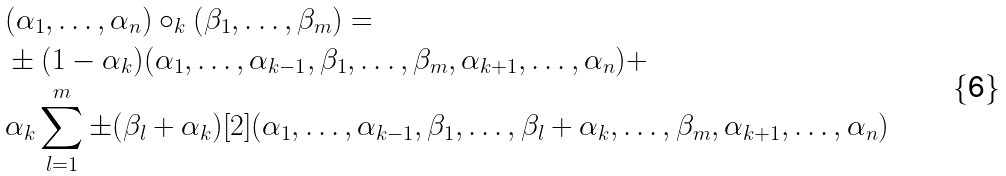Convert formula to latex. <formula><loc_0><loc_0><loc_500><loc_500>& ( \alpha _ { 1 } , \dots , \alpha _ { n } ) \circ _ { k } ( \beta _ { 1 } , \dots , \beta _ { m } ) = \\ & \pm ( 1 - \alpha _ { k } ) ( \alpha _ { 1 } , \dots , \alpha _ { k - 1 } , \beta _ { 1 } , \dots , \beta _ { m } , \alpha _ { k + 1 } , \dots , \alpha _ { n } ) + \\ & \alpha _ { k } \sum _ { l = 1 } ^ { m } \pm ( \beta _ { l } + \alpha _ { k } ) [ 2 ] ( \alpha _ { 1 } , \dots , \alpha _ { k - 1 } , \beta _ { 1 } , \dots , \beta _ { l } + \alpha _ { k } , \dots , \beta _ { m } , \alpha _ { k + 1 } , \dots , \alpha _ { n } )</formula> 